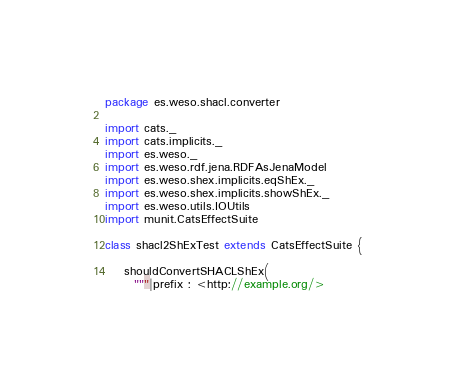<code> <loc_0><loc_0><loc_500><loc_500><_Scala_>package es.weso.shacl.converter

import cats._
import cats.implicits._
import es.weso._
import es.weso.rdf.jena.RDFAsJenaModel
import es.weso.shex.implicits.eqShEx._
import es.weso.shex.implicits.showShEx._
import es.weso.utils.IOUtils
import munit.CatsEffectSuite

class shacl2ShExTest extends CatsEffectSuite {

    shouldConvertSHACLShEx(
      """|prefix : <http://example.org/></code> 